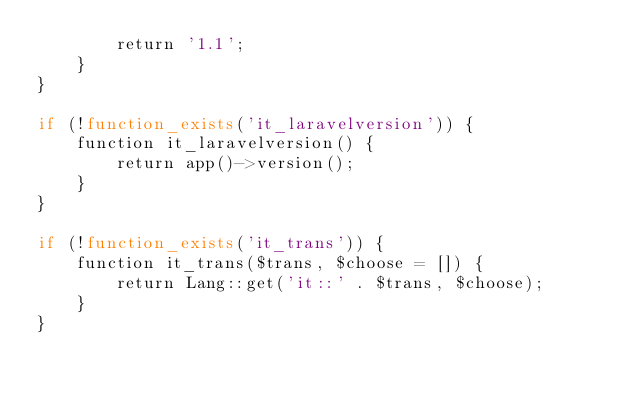<code> <loc_0><loc_0><loc_500><loc_500><_PHP_>		return '1.1';
	}
}

if (!function_exists('it_laravelversion')) {
	function it_laravelversion() {
		return app()->version();
	}
}

if (!function_exists('it_trans')) {
	function it_trans($trans, $choose = []) {
		return Lang::get('it::' . $trans, $choose);
	}
}
</code> 